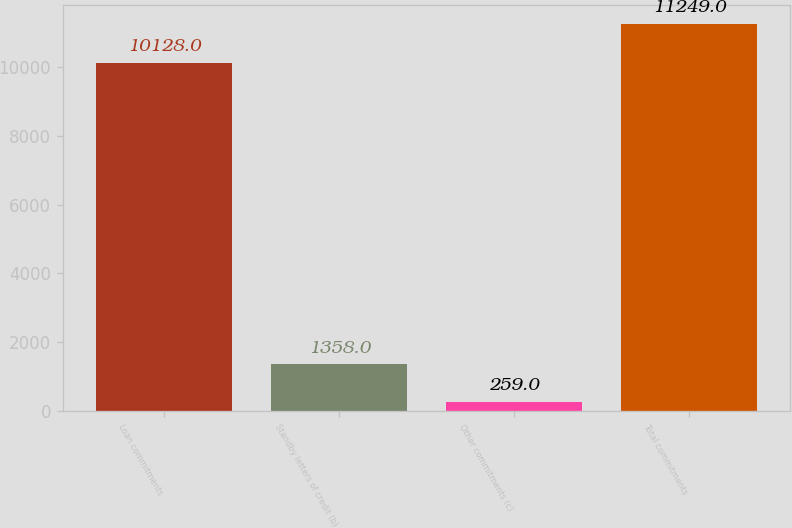<chart> <loc_0><loc_0><loc_500><loc_500><bar_chart><fcel>Loan commitments<fcel>Standby letters of credit (b)<fcel>Other commitments (c)<fcel>Total commitments<nl><fcel>10128<fcel>1358<fcel>259<fcel>11249<nl></chart> 